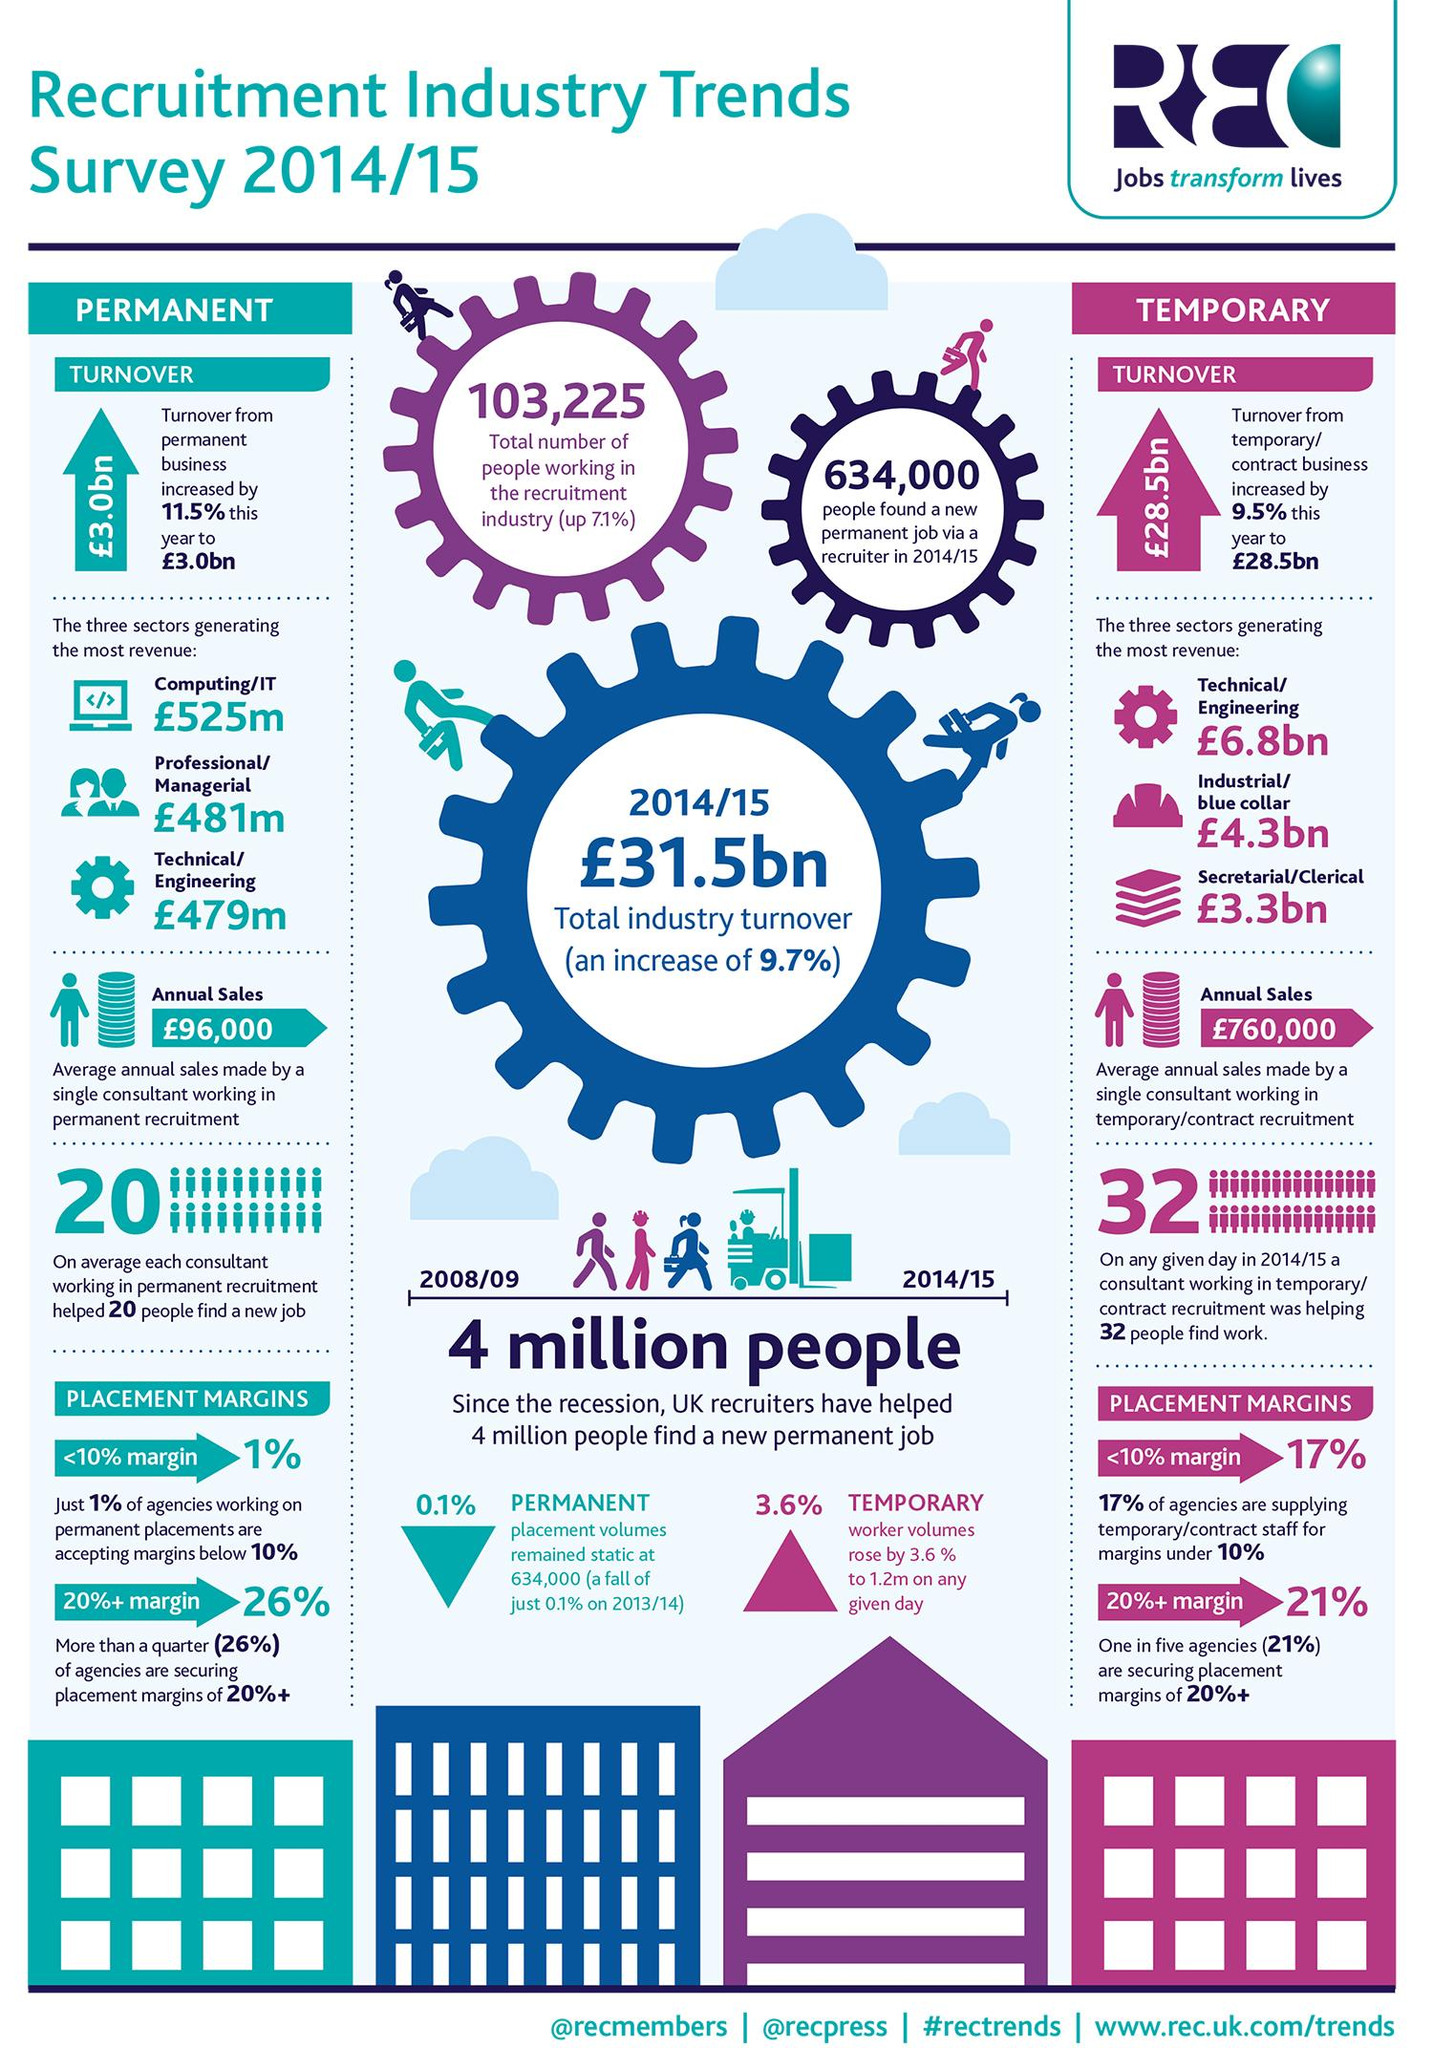Identify some key points in this picture. The professional/managerial sector is generating the second highest revenue in the permanent business industry. The turnover of permanent business has increased by 11.5% compared to the previous period. According to a recent survey, a significant portion of agencies are securing placement margins of 20% or more in their permanent business. Specifically, 26% of agencies are achieving these high margins. The industrial/blue collar sector in temporary business is generating the second highest revenue. The difference in revenue between industrial/blue collar workers and secretarial/clerical workers is estimated to be approximately 1 trillion dollars. 